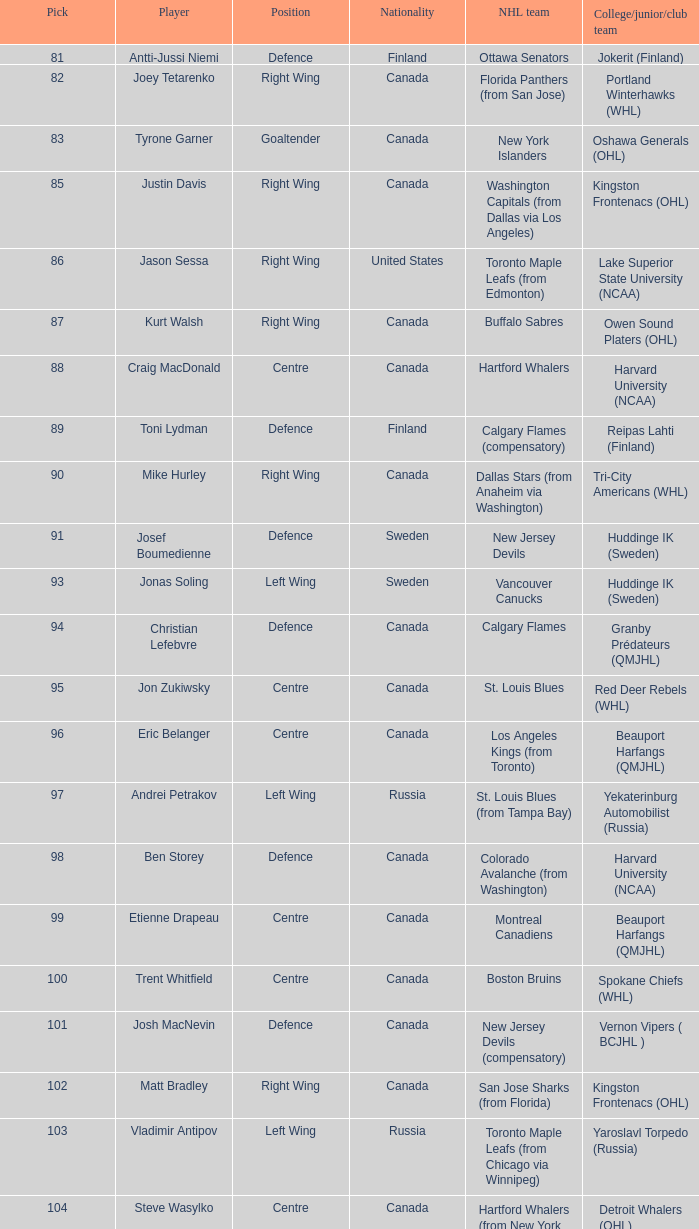How many draft pick positions did Matt Bradley have? 1.0. 